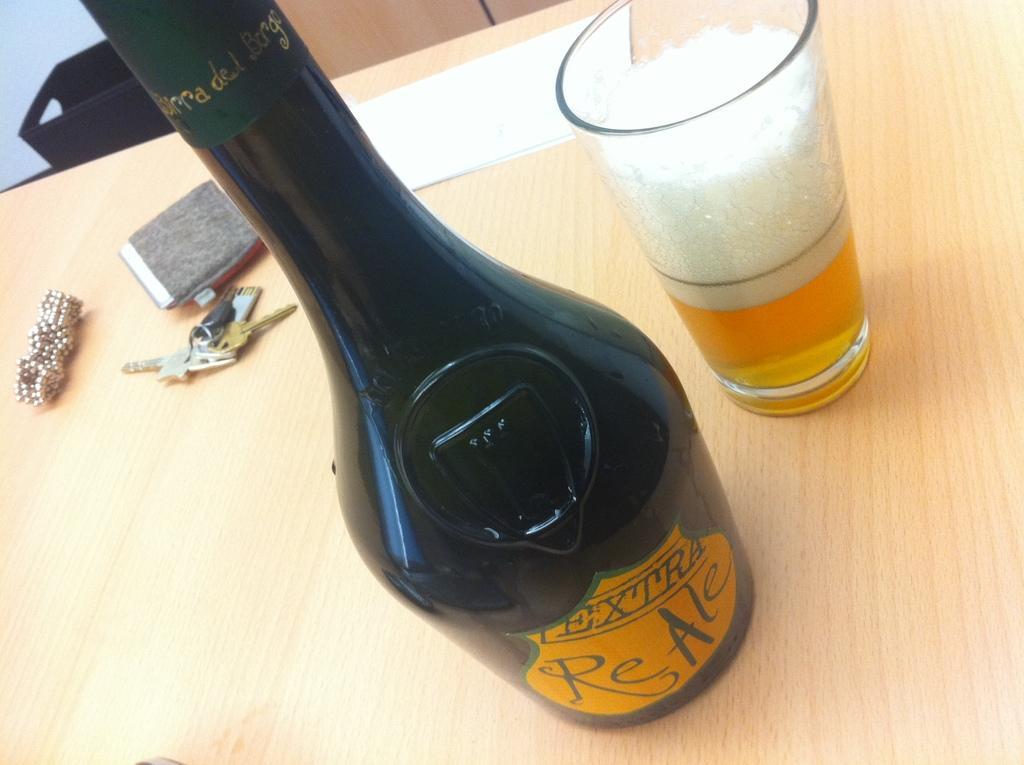Can you describe this image briefly? In this image I can see a bottle, a glass and other objects on a wooden surface. Here I can see some objects. 